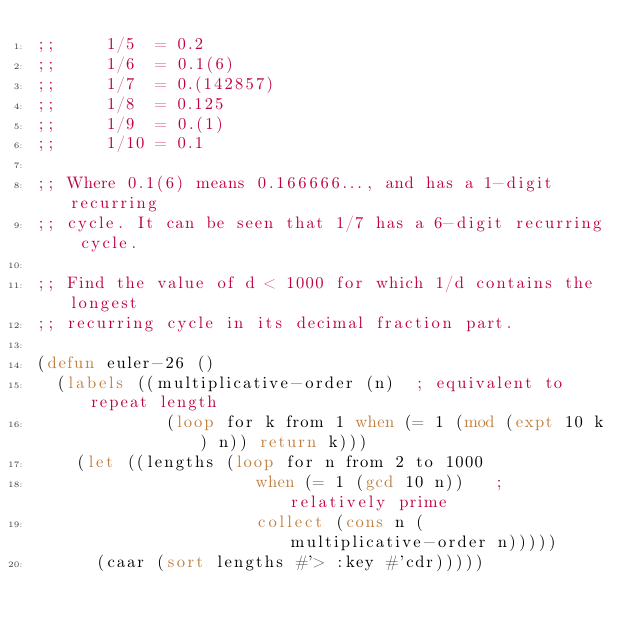<code> <loc_0><loc_0><loc_500><loc_500><_Lisp_>;;     1/5  = 0.2
;;     1/6  = 0.1(6)
;;     1/7  = 0.(142857)
;;     1/8  = 0.125
;;     1/9  = 0.(1)
;;     1/10 = 0.1

;; Where 0.1(6) means 0.166666..., and has a 1-digit recurring
;; cycle. It can be seen that 1/7 has a 6-digit recurring cycle.

;; Find the value of d < 1000 for which 1/d contains the longest
;; recurring cycle in its decimal fraction part.

(defun euler-26 ()
  (labels ((multiplicative-order (n)  ; equivalent to repeat length
             (loop for k from 1 when (= 1 (mod (expt 10 k) n)) return k)))
    (let ((lengths (loop for n from 2 to 1000
                      when (= 1 (gcd 10 n))   ; relatively prime
                      collect (cons n (multiplicative-order n)))))
      (caar (sort lengths #'> :key #'cdr)))))
</code> 